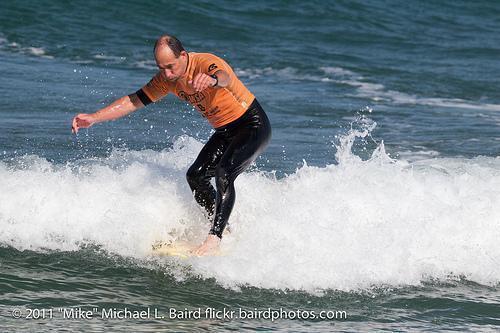How many people are shown?
Give a very brief answer. 1. 